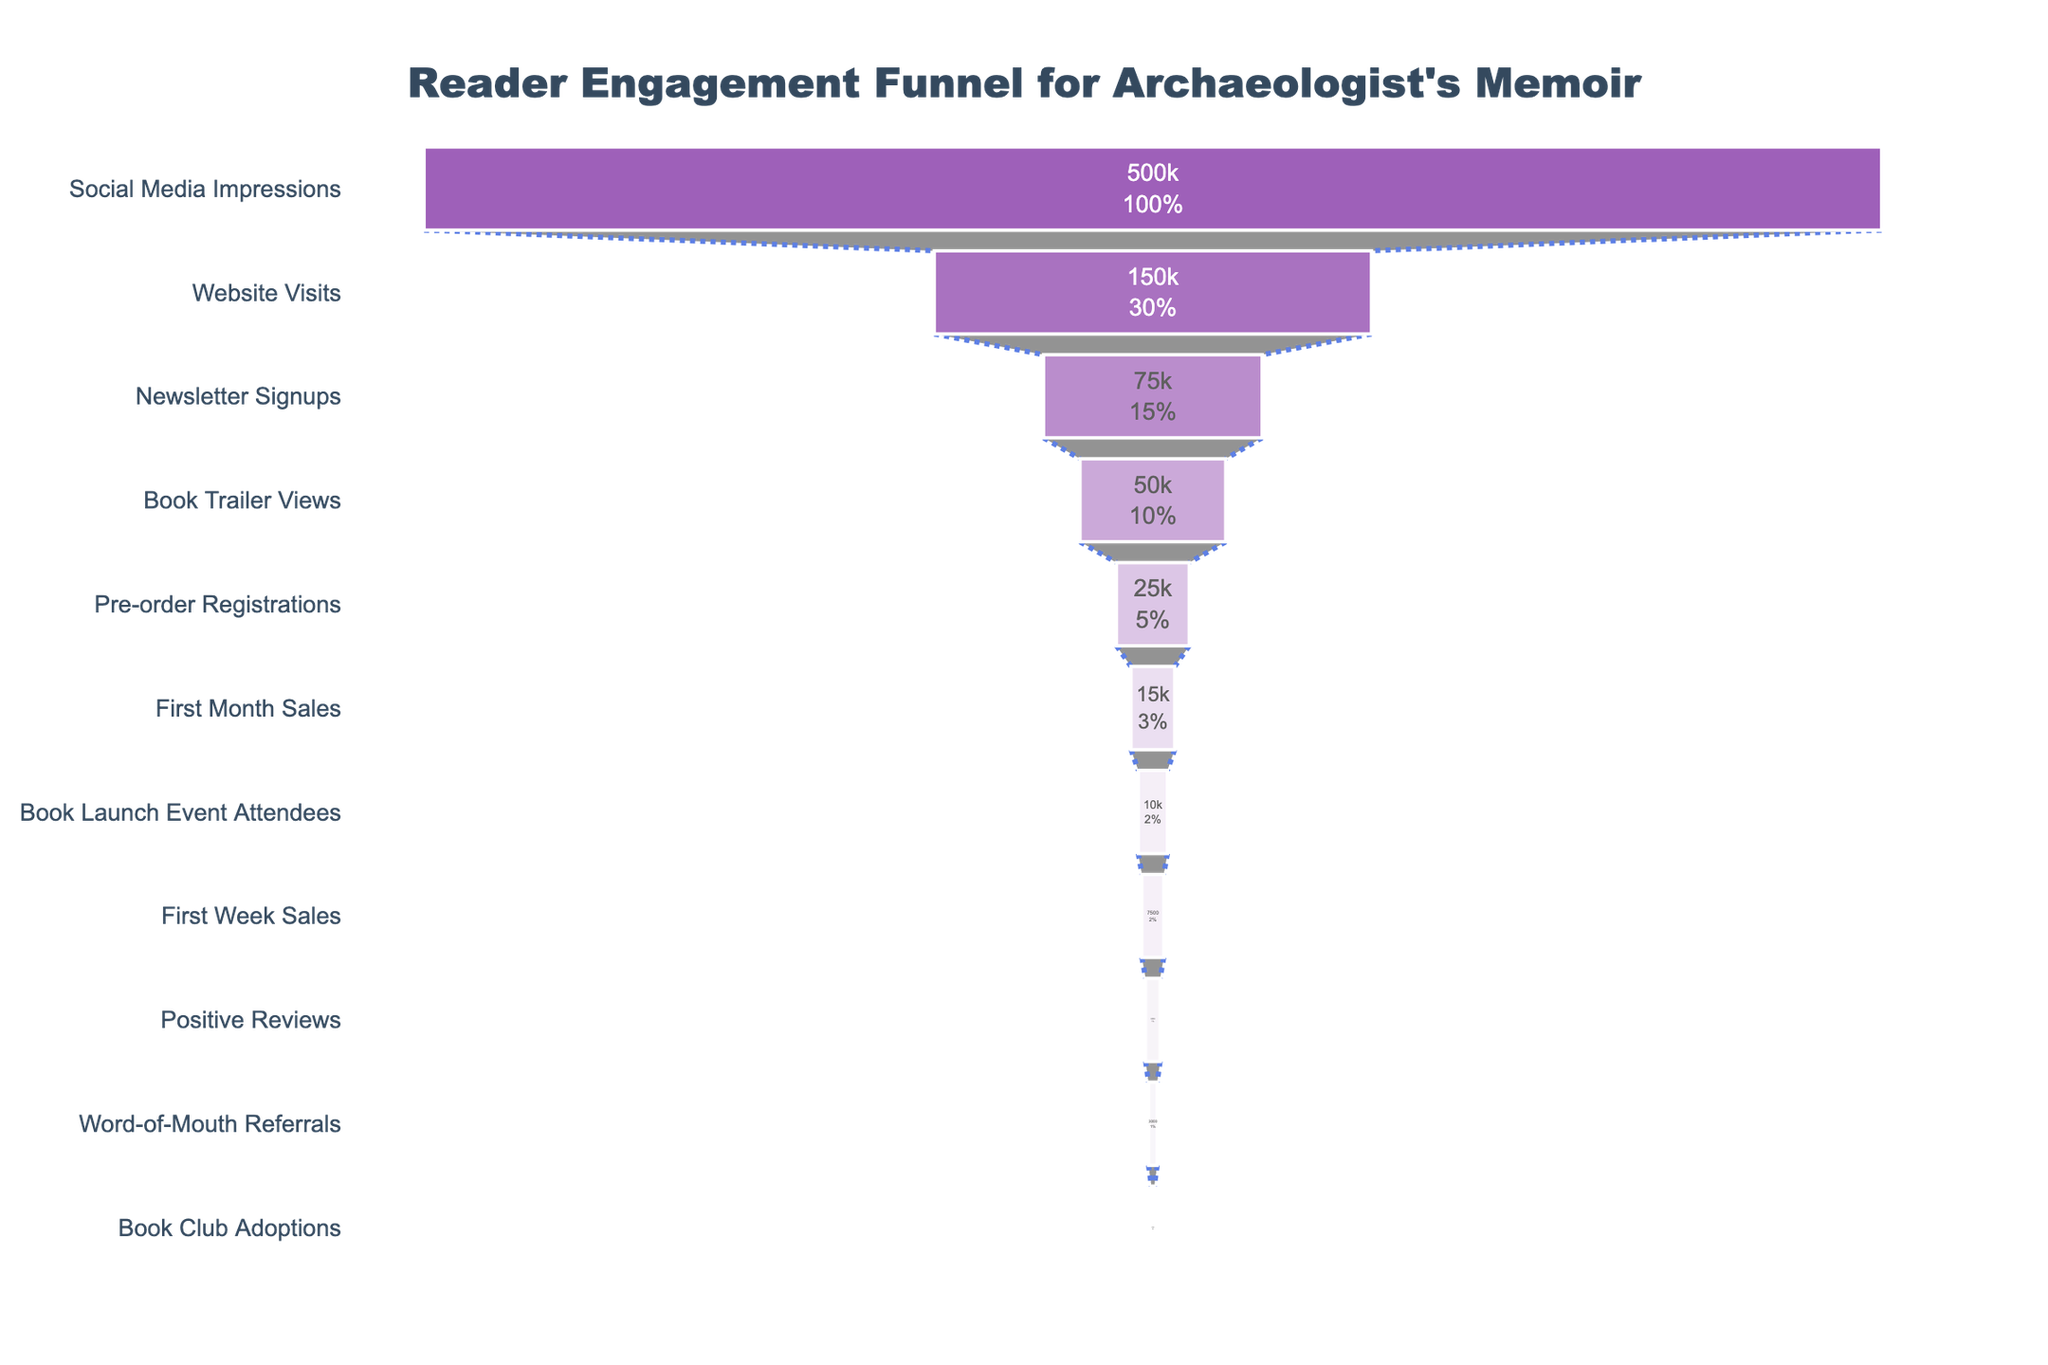what is the title of the figure? The title of the figure is displayed at the top center of the chart. It is written clearly and distinguishes the context of the data presented in the funnel.
Answer: Reader Engagement Funnel for Archaeologist's Memoir How many stages are there in the funnel chart? The stages in the funnel chart can be counted by observing the distinct sections presented in the funnel. Each stage represents a specific phase in the reader engagement process, from initial interest to book club adoptions.
Answer: 11 What stage has the highest number of readers? To determine the stage with the highest number of readers, look at the top section of the funnel chart where the widest part is located. This part represents the stage with the largest audience.
Answer: Social Media Impressions Which stage immediately follows 'Book Trailer Views'? To find the next stage after 'Book Trailer Views,' look directly below this segment in the funnel chart. Each stage proceeds sequentially down the funnel.
Answer: Pre-order Registrations What is the difference in the number of readers between 'Website Visits' and 'Positive Reviews'? First, identify the number of readers for 'Website Visits' and 'Positive Reviews,' then subtract the latter from the former (150,000 - 5,000).
Answer: 145,000 Which stage has fewer readers: 'First Month Sales' or 'Pre-order Registrations'? Compare the number of readers listed for 'First Month Sales' and 'Pre-order Registrations.' The stage with the smaller number indicates fewer readers.
Answer: Pre-order Registrations What is the percentage decrease in readers from 'Book Launch Event Attendees' to 'First Month Sales'? Calculate the decrease by subtracting 'First Month Sales' from 'Book Launch Event Attendees,' then divide by 'Book Launch Event Attendees' and multiply by 100 [(10,000-15,000) / 10,000 * 100].
Answer: -50% Is the number of 'Newsletter Signups' greater than the number of 'First Week Sales'? Compare the values for 'Newsletter Signups' and 'First Week Sales.' The stage with a higher value answers the question.
Answer: Yes How many readers are reduced between 'Social Media Impressions' and 'Book Trailer Views'? Subtract the number of readers for 'Book Trailer Views' from 'Social Media Impressions' (500,000 - 50,000).
Answer: 450,000 